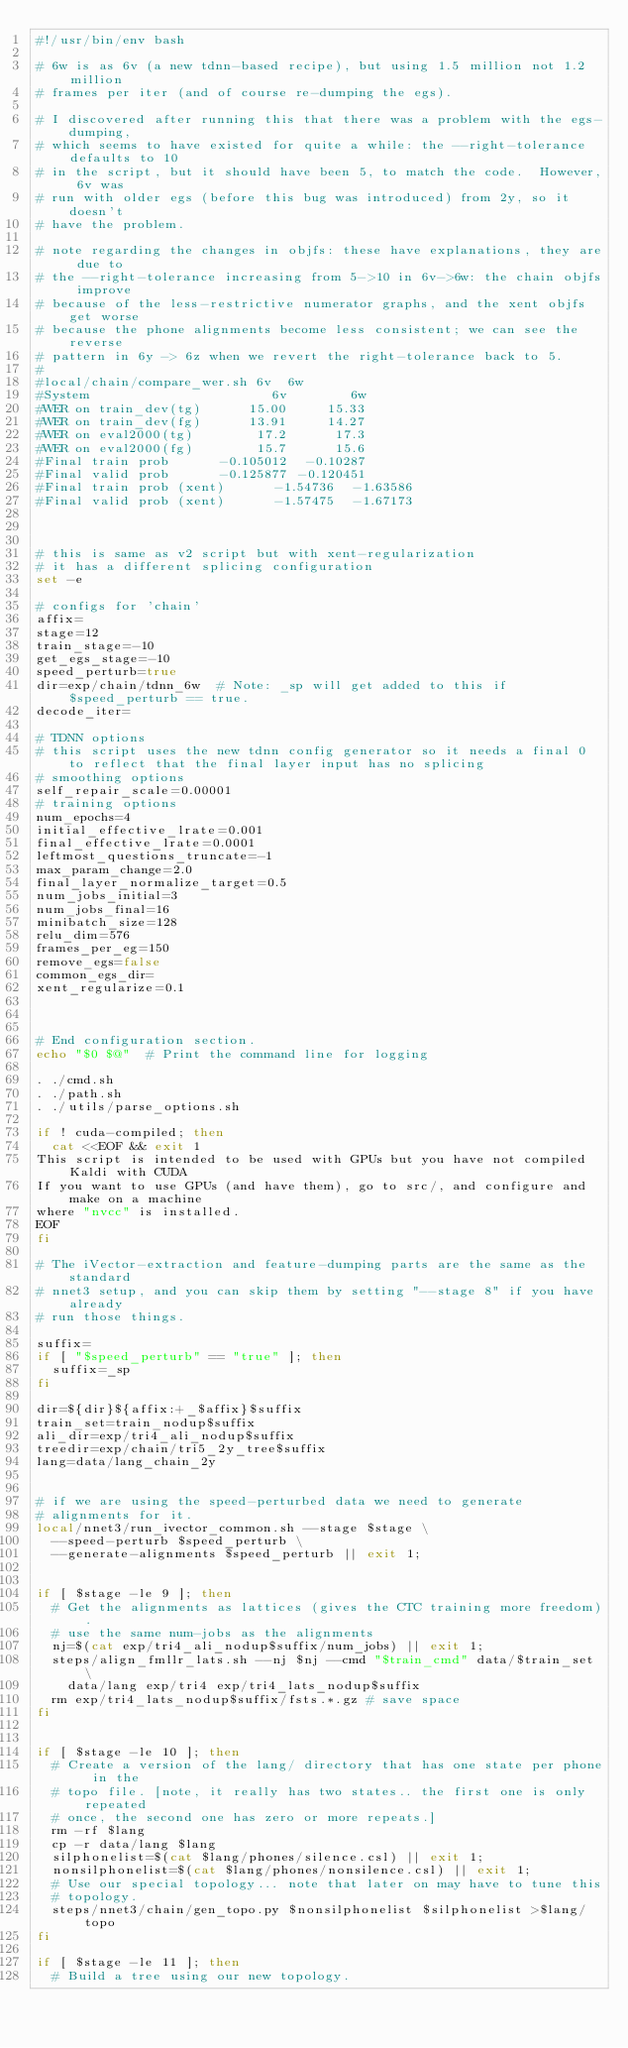Convert code to text. <code><loc_0><loc_0><loc_500><loc_500><_Bash_>#!/usr/bin/env bash

# 6w is as 6v (a new tdnn-based recipe), but using 1.5 million not 1.2 million
# frames per iter (and of course re-dumping the egs).

# I discovered after running this that there was a problem with the egs-dumping,
# which seems to have existed for quite a while: the --right-tolerance defaults to 10
# in the script, but it should have been 5, to match the code.  However, 6v was
# run with older egs (before this bug was introduced) from 2y, so it doesn't
# have the problem.

# note regarding the changes in objfs: these have explanations, they are due to
# the --right-tolerance increasing from 5->10 in 6v->6w: the chain objfs improve
# because of the less-restrictive numerator graphs, and the xent objfs get worse
# because the phone alignments become less consistent; we can see the reverse
# pattern in 6y -> 6z when we revert the right-tolerance back to 5.
#
#local/chain/compare_wer.sh 6v  6w
#System                       6v        6w
#WER on train_dev(tg)      15.00     15.33
#WER on train_dev(fg)      13.91     14.27
#WER on eval2000(tg)        17.2      17.3
#WER on eval2000(fg)        15.7      15.6
#Final train prob      -0.105012  -0.10287
#Final valid prob      -0.125877 -0.120451
#Final train prob (xent)      -1.54736  -1.63586
#Final valid prob (xent)      -1.57475  -1.67173



# this is same as v2 script but with xent-regularization
# it has a different splicing configuration
set -e

# configs for 'chain'
affix=
stage=12
train_stage=-10
get_egs_stage=-10
speed_perturb=true
dir=exp/chain/tdnn_6w  # Note: _sp will get added to this if $speed_perturb == true.
decode_iter=

# TDNN options
# this script uses the new tdnn config generator so it needs a final 0 to reflect that the final layer input has no splicing
# smoothing options
self_repair_scale=0.00001
# training options
num_epochs=4
initial_effective_lrate=0.001
final_effective_lrate=0.0001
leftmost_questions_truncate=-1
max_param_change=2.0
final_layer_normalize_target=0.5
num_jobs_initial=3
num_jobs_final=16
minibatch_size=128
relu_dim=576
frames_per_eg=150
remove_egs=false
common_egs_dir=
xent_regularize=0.1



# End configuration section.
echo "$0 $@"  # Print the command line for logging

. ./cmd.sh
. ./path.sh
. ./utils/parse_options.sh

if ! cuda-compiled; then
  cat <<EOF && exit 1
This script is intended to be used with GPUs but you have not compiled Kaldi with CUDA
If you want to use GPUs (and have them), go to src/, and configure and make on a machine
where "nvcc" is installed.
EOF
fi

# The iVector-extraction and feature-dumping parts are the same as the standard
# nnet3 setup, and you can skip them by setting "--stage 8" if you have already
# run those things.

suffix=
if [ "$speed_perturb" == "true" ]; then
  suffix=_sp
fi

dir=${dir}${affix:+_$affix}$suffix
train_set=train_nodup$suffix
ali_dir=exp/tri4_ali_nodup$suffix
treedir=exp/chain/tri5_2y_tree$suffix
lang=data/lang_chain_2y


# if we are using the speed-perturbed data we need to generate
# alignments for it.
local/nnet3/run_ivector_common.sh --stage $stage \
  --speed-perturb $speed_perturb \
  --generate-alignments $speed_perturb || exit 1;


if [ $stage -le 9 ]; then
  # Get the alignments as lattices (gives the CTC training more freedom).
  # use the same num-jobs as the alignments
  nj=$(cat exp/tri4_ali_nodup$suffix/num_jobs) || exit 1;
  steps/align_fmllr_lats.sh --nj $nj --cmd "$train_cmd" data/$train_set \
    data/lang exp/tri4 exp/tri4_lats_nodup$suffix
  rm exp/tri4_lats_nodup$suffix/fsts.*.gz # save space
fi


if [ $stage -le 10 ]; then
  # Create a version of the lang/ directory that has one state per phone in the
  # topo file. [note, it really has two states.. the first one is only repeated
  # once, the second one has zero or more repeats.]
  rm -rf $lang
  cp -r data/lang $lang
  silphonelist=$(cat $lang/phones/silence.csl) || exit 1;
  nonsilphonelist=$(cat $lang/phones/nonsilence.csl) || exit 1;
  # Use our special topology... note that later on may have to tune this
  # topology.
  steps/nnet3/chain/gen_topo.py $nonsilphonelist $silphonelist >$lang/topo
fi

if [ $stage -le 11 ]; then
  # Build a tree using our new topology.</code> 